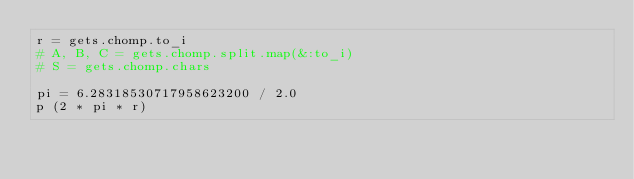Convert code to text. <code><loc_0><loc_0><loc_500><loc_500><_Ruby_>r = gets.chomp.to_i
# A, B, C = gets.chomp.split.map(&:to_i)
# S = gets.chomp.chars

pi = 6.28318530717958623200 / 2.0
p (2 * pi * r)
</code> 